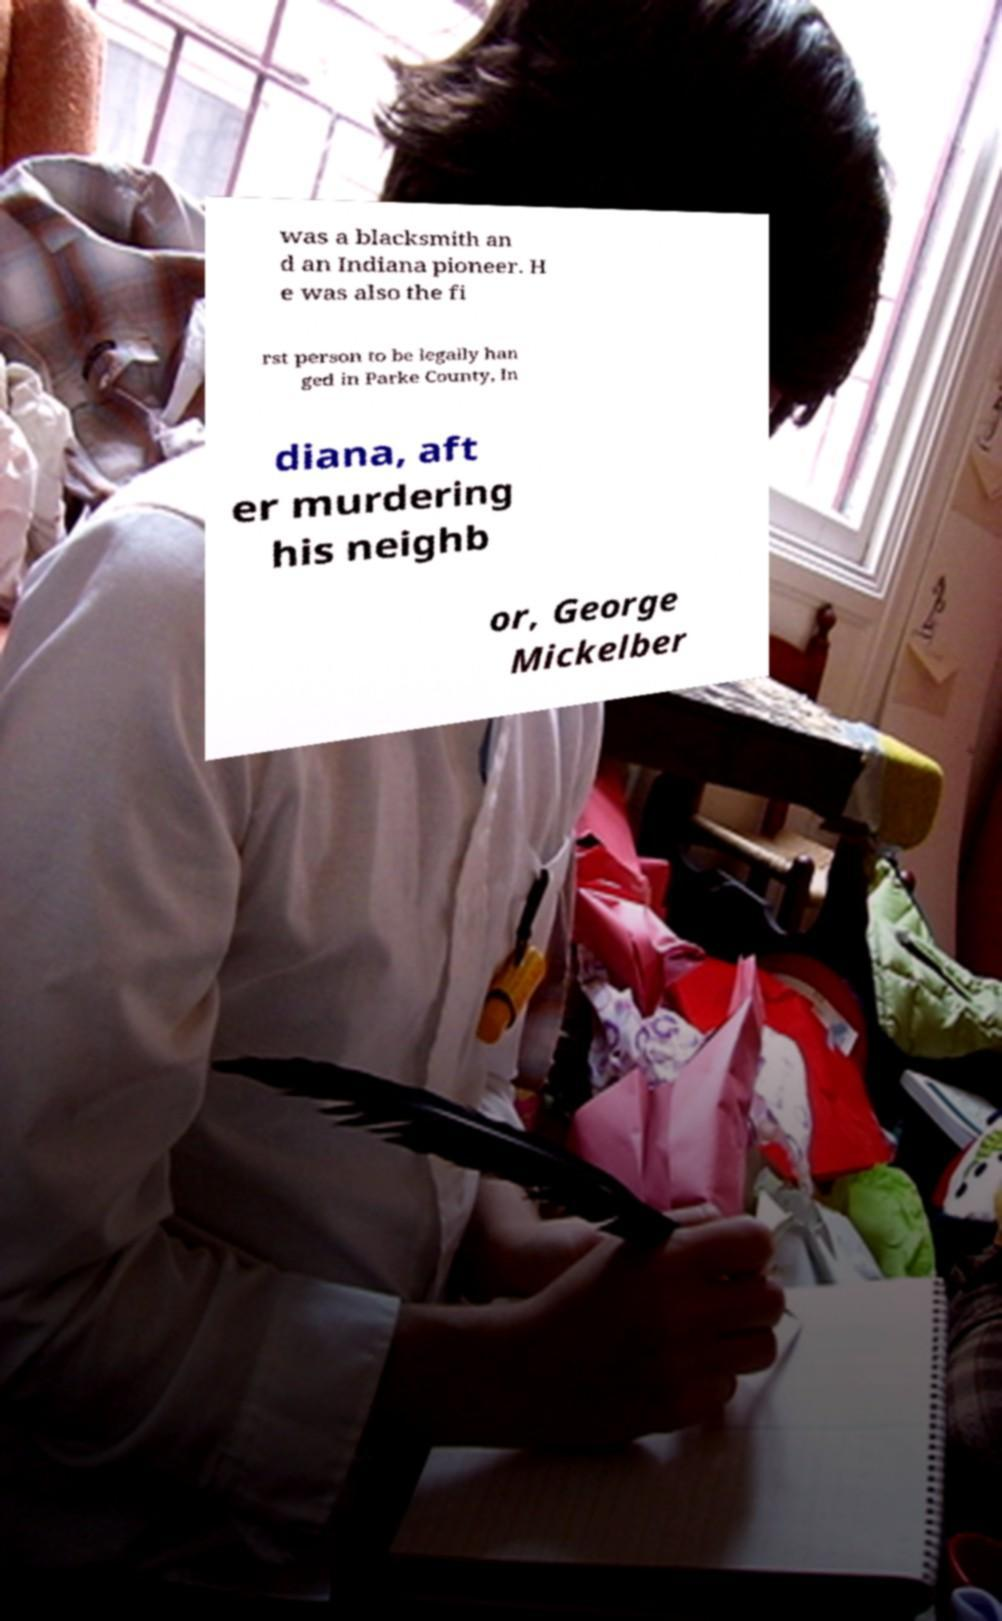Can you read and provide the text displayed in the image?This photo seems to have some interesting text. Can you extract and type it out for me? was a blacksmith an d an Indiana pioneer. H e was also the fi rst person to be legally han ged in Parke County, In diana, aft er murdering his neighb or, George Mickelber 